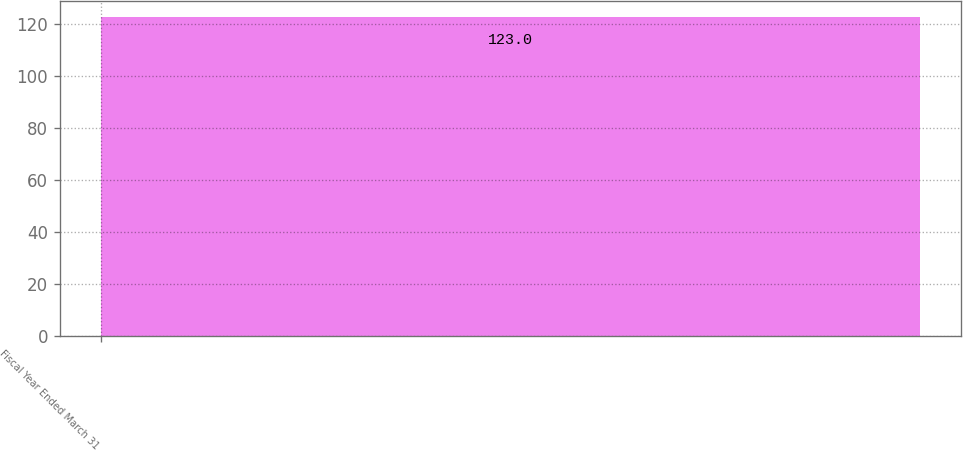<chart> <loc_0><loc_0><loc_500><loc_500><bar_chart><fcel>Fiscal Year Ended March 31<nl><fcel>123<nl></chart> 